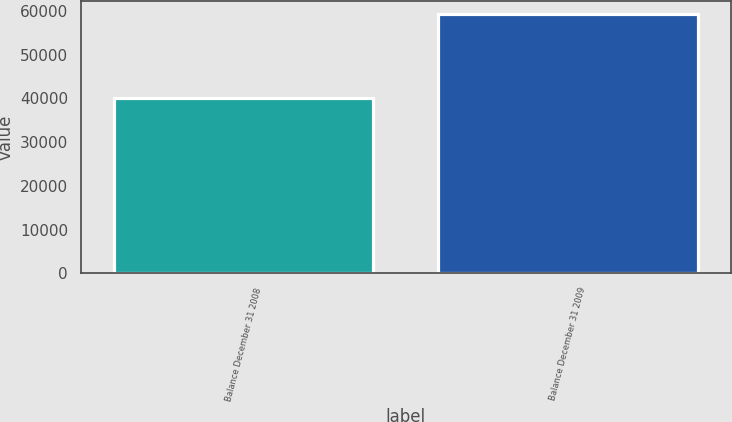<chart> <loc_0><loc_0><loc_500><loc_500><bar_chart><fcel>Balance December 31 2008<fcel>Balance December 31 2009<nl><fcel>40204<fcel>59399<nl></chart> 